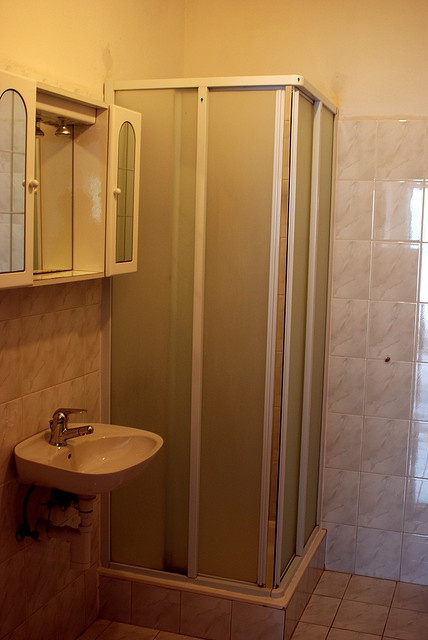Describe the objects in this image and their specific colors. I can see a sink in orange, brown, maroon, and black tones in this image. 